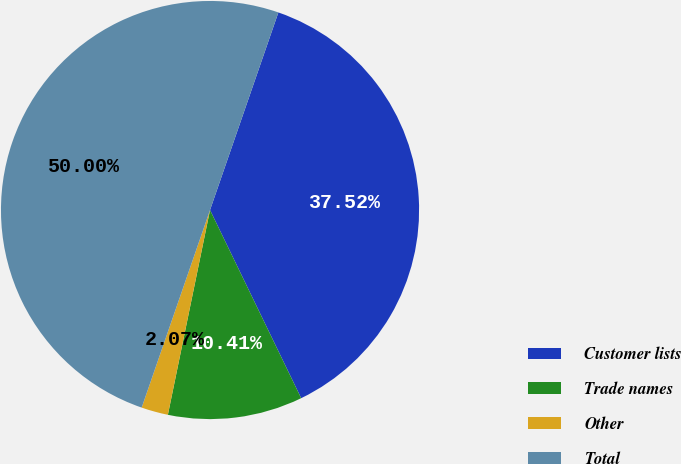<chart> <loc_0><loc_0><loc_500><loc_500><pie_chart><fcel>Customer lists<fcel>Trade names<fcel>Other<fcel>Total<nl><fcel>37.52%<fcel>10.41%<fcel>2.07%<fcel>50.0%<nl></chart> 